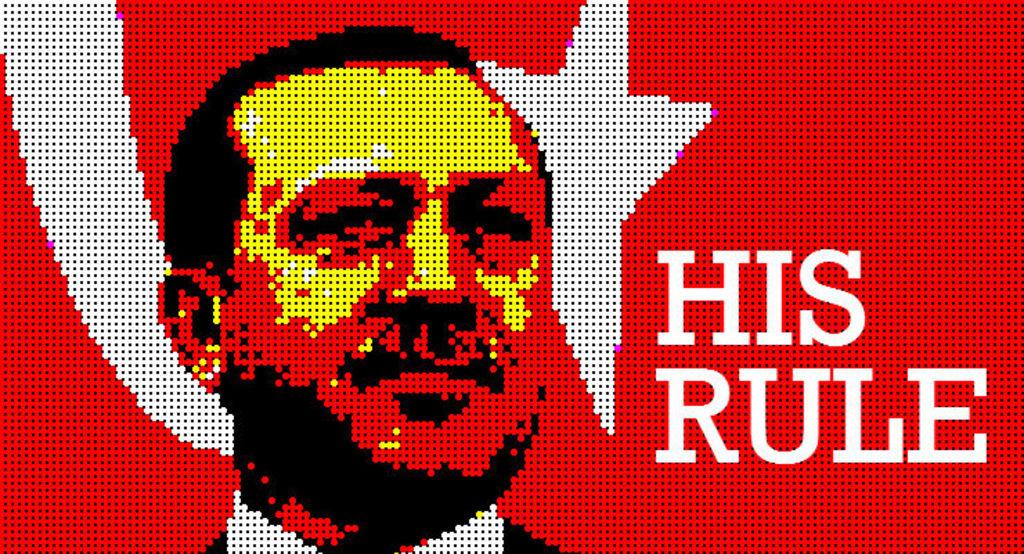Who is this picture say is ruling?
Your answer should be very brief. His. What does the sign purport he can do?
Offer a terse response. Rule. 